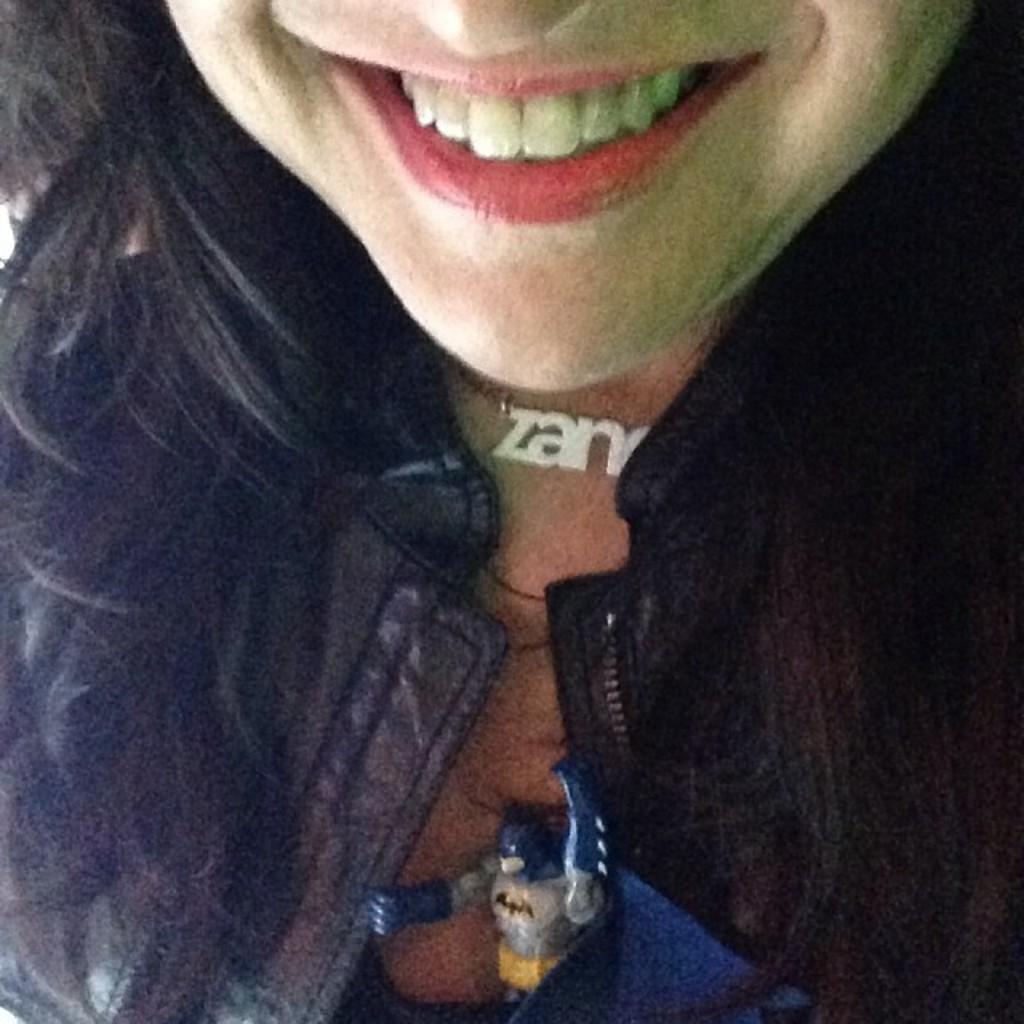Who is present in the picture? There is a woman in the picture. What is the woman wearing in the picture? The woman is wearing a coat and a chain. Can you describe any other objects in the picture? Yes, there is a Batman toy in the picture. What type of account does the kitten have with the Batman toy in the image? There is no kitten present in the image, so it is not possible to answer that question. 